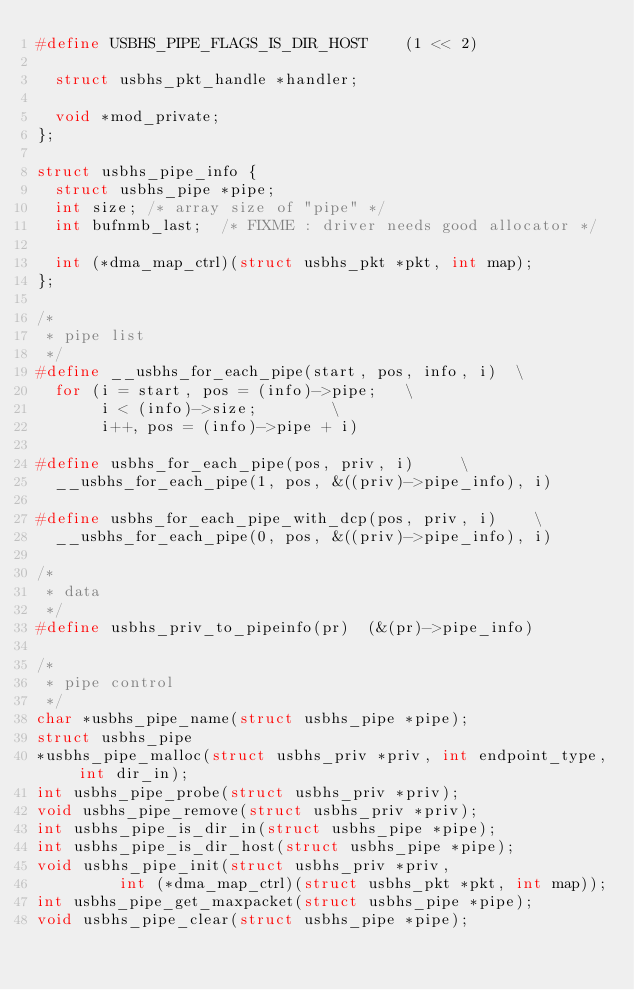<code> <loc_0><loc_0><loc_500><loc_500><_C_>#define USBHS_PIPE_FLAGS_IS_DIR_HOST		(1 << 2)

	struct usbhs_pkt_handle *handler;

	void *mod_private;
};

struct usbhs_pipe_info {
	struct usbhs_pipe *pipe;
	int size;	/* array size of "pipe" */
	int bufnmb_last;	/* FIXME : driver needs good allocator */

	int (*dma_map_ctrl)(struct usbhs_pkt *pkt, int map);
};

/*
 * pipe list
 */
#define __usbhs_for_each_pipe(start, pos, info, i)	\
	for (i = start, pos = (info)->pipe;		\
	     i < (info)->size;				\
	     i++, pos = (info)->pipe + i)

#define usbhs_for_each_pipe(pos, priv, i)			\
	__usbhs_for_each_pipe(1, pos, &((priv)->pipe_info), i)

#define usbhs_for_each_pipe_with_dcp(pos, priv, i)		\
	__usbhs_for_each_pipe(0, pos, &((priv)->pipe_info), i)

/*
 * data
 */
#define usbhs_priv_to_pipeinfo(pr)	(&(pr)->pipe_info)

/*
 * pipe control
 */
char *usbhs_pipe_name(struct usbhs_pipe *pipe);
struct usbhs_pipe
*usbhs_pipe_malloc(struct usbhs_priv *priv, int endpoint_type, int dir_in);
int usbhs_pipe_probe(struct usbhs_priv *priv);
void usbhs_pipe_remove(struct usbhs_priv *priv);
int usbhs_pipe_is_dir_in(struct usbhs_pipe *pipe);
int usbhs_pipe_is_dir_host(struct usbhs_pipe *pipe);
void usbhs_pipe_init(struct usbhs_priv *priv,
		     int (*dma_map_ctrl)(struct usbhs_pkt *pkt, int map));
int usbhs_pipe_get_maxpacket(struct usbhs_pipe *pipe);
void usbhs_pipe_clear(struct usbhs_pipe *pipe);</code> 